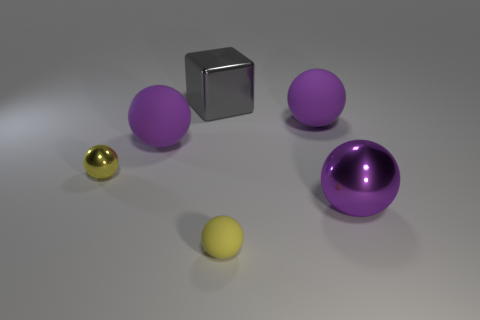Is the color of the small matte object the same as the small thing left of the block?
Provide a succinct answer. Yes. Do the big block and the large ball in front of the tiny yellow metal thing have the same material?
Offer a terse response. Yes. What number of things are either objects in front of the tiny shiny object or small yellow metallic spheres?
Your response must be concise. 3. Is there another tiny sphere that has the same color as the tiny metallic ball?
Offer a very short reply. Yes. Is the shape of the large gray shiny object the same as the object in front of the purple metallic thing?
Your response must be concise. No. What number of purple spheres are behind the tiny yellow metallic thing and right of the small rubber object?
Your answer should be compact. 1. There is another yellow thing that is the same shape as the tiny matte object; what is its material?
Your answer should be compact. Metal. What size is the metallic ball that is to the right of the big rubber thing to the right of the large gray cube?
Provide a succinct answer. Large. Are any yellow things visible?
Your answer should be compact. Yes. There is a large purple sphere that is to the right of the metallic block and to the left of the purple metallic ball; what is its material?
Your answer should be compact. Rubber. 